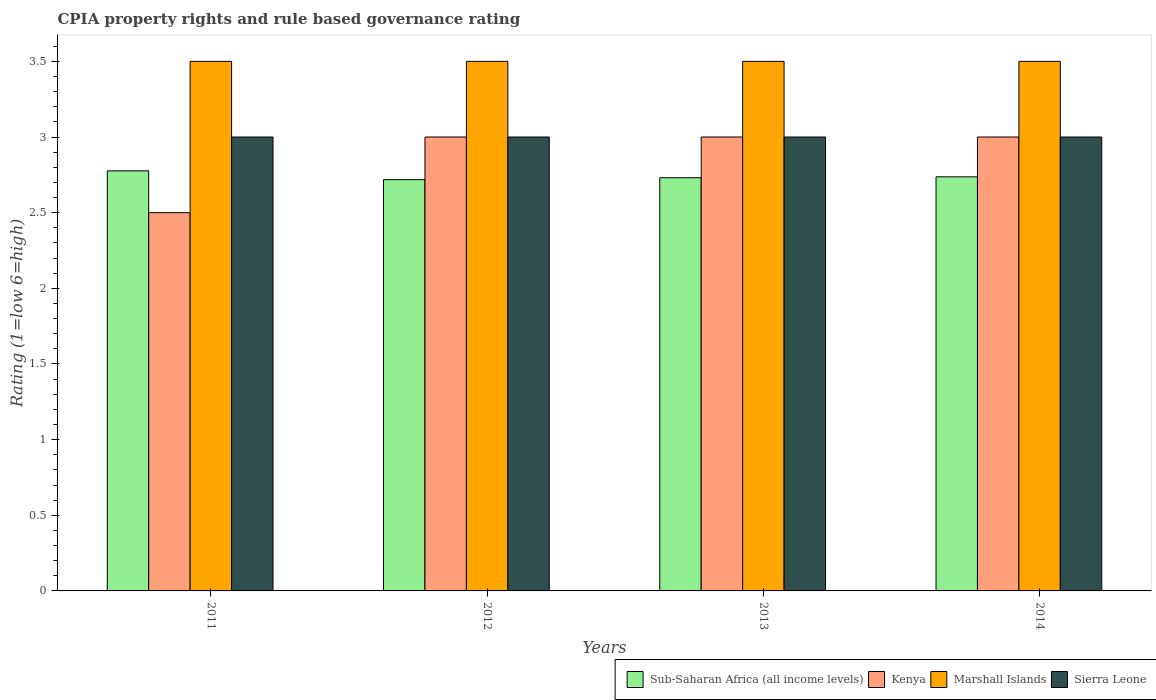How many different coloured bars are there?
Keep it short and to the point. 4. Are the number of bars per tick equal to the number of legend labels?
Make the answer very short. Yes. How many bars are there on the 1st tick from the left?
Provide a short and direct response. 4. How many bars are there on the 3rd tick from the right?
Offer a very short reply. 4. What is the label of the 2nd group of bars from the left?
Keep it short and to the point. 2012. In how many cases, is the number of bars for a given year not equal to the number of legend labels?
Ensure brevity in your answer.  0. What is the CPIA rating in Kenya in 2013?
Provide a short and direct response. 3. Across all years, what is the maximum CPIA rating in Sub-Saharan Africa (all income levels)?
Your answer should be compact. 2.78. In which year was the CPIA rating in Kenya minimum?
Provide a short and direct response. 2011. What is the total CPIA rating in Sub-Saharan Africa (all income levels) in the graph?
Your answer should be compact. 10.96. What is the difference between the CPIA rating in Sub-Saharan Africa (all income levels) in 2011 and the CPIA rating in Kenya in 2012?
Your answer should be compact. -0.22. What is the average CPIA rating in Marshall Islands per year?
Provide a short and direct response. 3.5. In the year 2011, what is the difference between the CPIA rating in Marshall Islands and CPIA rating in Sub-Saharan Africa (all income levels)?
Offer a very short reply. 0.72. What is the ratio of the CPIA rating in Sub-Saharan Africa (all income levels) in 2011 to that in 2014?
Your response must be concise. 1.01. Is the difference between the CPIA rating in Marshall Islands in 2012 and 2013 greater than the difference between the CPIA rating in Sub-Saharan Africa (all income levels) in 2012 and 2013?
Provide a succinct answer. Yes. What is the difference between the highest and the second highest CPIA rating in Sub-Saharan Africa (all income levels)?
Give a very brief answer. 0.04. In how many years, is the CPIA rating in Marshall Islands greater than the average CPIA rating in Marshall Islands taken over all years?
Offer a terse response. 0. Is the sum of the CPIA rating in Kenya in 2011 and 2014 greater than the maximum CPIA rating in Marshall Islands across all years?
Make the answer very short. Yes. What does the 4th bar from the left in 2014 represents?
Provide a succinct answer. Sierra Leone. What does the 2nd bar from the right in 2011 represents?
Give a very brief answer. Marshall Islands. Is it the case that in every year, the sum of the CPIA rating in Marshall Islands and CPIA rating in Kenya is greater than the CPIA rating in Sub-Saharan Africa (all income levels)?
Make the answer very short. Yes. How many years are there in the graph?
Keep it short and to the point. 4. What is the difference between two consecutive major ticks on the Y-axis?
Give a very brief answer. 0.5. What is the title of the graph?
Your answer should be compact. CPIA property rights and rule based governance rating. What is the label or title of the Y-axis?
Your answer should be very brief. Rating (1=low 6=high). What is the Rating (1=low 6=high) in Sub-Saharan Africa (all income levels) in 2011?
Offer a very short reply. 2.78. What is the Rating (1=low 6=high) in Sub-Saharan Africa (all income levels) in 2012?
Provide a short and direct response. 2.72. What is the Rating (1=low 6=high) of Marshall Islands in 2012?
Your answer should be very brief. 3.5. What is the Rating (1=low 6=high) in Sub-Saharan Africa (all income levels) in 2013?
Make the answer very short. 2.73. What is the Rating (1=low 6=high) in Sierra Leone in 2013?
Your answer should be compact. 3. What is the Rating (1=low 6=high) in Sub-Saharan Africa (all income levels) in 2014?
Make the answer very short. 2.74. What is the Rating (1=low 6=high) in Marshall Islands in 2014?
Your answer should be compact. 3.5. What is the Rating (1=low 6=high) in Sierra Leone in 2014?
Ensure brevity in your answer.  3. Across all years, what is the maximum Rating (1=low 6=high) of Sub-Saharan Africa (all income levels)?
Your answer should be very brief. 2.78. Across all years, what is the maximum Rating (1=low 6=high) of Marshall Islands?
Offer a very short reply. 3.5. Across all years, what is the maximum Rating (1=low 6=high) of Sierra Leone?
Provide a succinct answer. 3. Across all years, what is the minimum Rating (1=low 6=high) in Sub-Saharan Africa (all income levels)?
Offer a very short reply. 2.72. What is the total Rating (1=low 6=high) in Sub-Saharan Africa (all income levels) in the graph?
Provide a succinct answer. 10.96. What is the difference between the Rating (1=low 6=high) of Sub-Saharan Africa (all income levels) in 2011 and that in 2012?
Give a very brief answer. 0.06. What is the difference between the Rating (1=low 6=high) of Sub-Saharan Africa (all income levels) in 2011 and that in 2013?
Provide a succinct answer. 0.05. What is the difference between the Rating (1=low 6=high) of Marshall Islands in 2011 and that in 2013?
Offer a terse response. 0. What is the difference between the Rating (1=low 6=high) in Sub-Saharan Africa (all income levels) in 2011 and that in 2014?
Give a very brief answer. 0.04. What is the difference between the Rating (1=low 6=high) in Kenya in 2011 and that in 2014?
Make the answer very short. -0.5. What is the difference between the Rating (1=low 6=high) in Sub-Saharan Africa (all income levels) in 2012 and that in 2013?
Your answer should be very brief. -0.01. What is the difference between the Rating (1=low 6=high) in Sierra Leone in 2012 and that in 2013?
Make the answer very short. 0. What is the difference between the Rating (1=low 6=high) of Sub-Saharan Africa (all income levels) in 2012 and that in 2014?
Ensure brevity in your answer.  -0.02. What is the difference between the Rating (1=low 6=high) in Kenya in 2012 and that in 2014?
Make the answer very short. 0. What is the difference between the Rating (1=low 6=high) of Marshall Islands in 2012 and that in 2014?
Ensure brevity in your answer.  0. What is the difference between the Rating (1=low 6=high) in Sub-Saharan Africa (all income levels) in 2013 and that in 2014?
Give a very brief answer. -0.01. What is the difference between the Rating (1=low 6=high) in Kenya in 2013 and that in 2014?
Offer a very short reply. 0. What is the difference between the Rating (1=low 6=high) of Sub-Saharan Africa (all income levels) in 2011 and the Rating (1=low 6=high) of Kenya in 2012?
Provide a short and direct response. -0.22. What is the difference between the Rating (1=low 6=high) of Sub-Saharan Africa (all income levels) in 2011 and the Rating (1=low 6=high) of Marshall Islands in 2012?
Ensure brevity in your answer.  -0.72. What is the difference between the Rating (1=low 6=high) in Sub-Saharan Africa (all income levels) in 2011 and the Rating (1=low 6=high) in Sierra Leone in 2012?
Your answer should be very brief. -0.22. What is the difference between the Rating (1=low 6=high) of Marshall Islands in 2011 and the Rating (1=low 6=high) of Sierra Leone in 2012?
Your answer should be very brief. 0.5. What is the difference between the Rating (1=low 6=high) in Sub-Saharan Africa (all income levels) in 2011 and the Rating (1=low 6=high) in Kenya in 2013?
Make the answer very short. -0.22. What is the difference between the Rating (1=low 6=high) in Sub-Saharan Africa (all income levels) in 2011 and the Rating (1=low 6=high) in Marshall Islands in 2013?
Your answer should be compact. -0.72. What is the difference between the Rating (1=low 6=high) in Sub-Saharan Africa (all income levels) in 2011 and the Rating (1=low 6=high) in Sierra Leone in 2013?
Offer a very short reply. -0.22. What is the difference between the Rating (1=low 6=high) in Kenya in 2011 and the Rating (1=low 6=high) in Marshall Islands in 2013?
Your answer should be very brief. -1. What is the difference between the Rating (1=low 6=high) of Kenya in 2011 and the Rating (1=low 6=high) of Sierra Leone in 2013?
Your response must be concise. -0.5. What is the difference between the Rating (1=low 6=high) of Marshall Islands in 2011 and the Rating (1=low 6=high) of Sierra Leone in 2013?
Your answer should be compact. 0.5. What is the difference between the Rating (1=low 6=high) of Sub-Saharan Africa (all income levels) in 2011 and the Rating (1=low 6=high) of Kenya in 2014?
Offer a very short reply. -0.22. What is the difference between the Rating (1=low 6=high) of Sub-Saharan Africa (all income levels) in 2011 and the Rating (1=low 6=high) of Marshall Islands in 2014?
Make the answer very short. -0.72. What is the difference between the Rating (1=low 6=high) of Sub-Saharan Africa (all income levels) in 2011 and the Rating (1=low 6=high) of Sierra Leone in 2014?
Make the answer very short. -0.22. What is the difference between the Rating (1=low 6=high) in Kenya in 2011 and the Rating (1=low 6=high) in Marshall Islands in 2014?
Offer a very short reply. -1. What is the difference between the Rating (1=low 6=high) of Marshall Islands in 2011 and the Rating (1=low 6=high) of Sierra Leone in 2014?
Your answer should be very brief. 0.5. What is the difference between the Rating (1=low 6=high) in Sub-Saharan Africa (all income levels) in 2012 and the Rating (1=low 6=high) in Kenya in 2013?
Your response must be concise. -0.28. What is the difference between the Rating (1=low 6=high) of Sub-Saharan Africa (all income levels) in 2012 and the Rating (1=low 6=high) of Marshall Islands in 2013?
Offer a terse response. -0.78. What is the difference between the Rating (1=low 6=high) of Sub-Saharan Africa (all income levels) in 2012 and the Rating (1=low 6=high) of Sierra Leone in 2013?
Offer a very short reply. -0.28. What is the difference between the Rating (1=low 6=high) of Kenya in 2012 and the Rating (1=low 6=high) of Marshall Islands in 2013?
Offer a terse response. -0.5. What is the difference between the Rating (1=low 6=high) of Sub-Saharan Africa (all income levels) in 2012 and the Rating (1=low 6=high) of Kenya in 2014?
Provide a succinct answer. -0.28. What is the difference between the Rating (1=low 6=high) of Sub-Saharan Africa (all income levels) in 2012 and the Rating (1=low 6=high) of Marshall Islands in 2014?
Your answer should be compact. -0.78. What is the difference between the Rating (1=low 6=high) of Sub-Saharan Africa (all income levels) in 2012 and the Rating (1=low 6=high) of Sierra Leone in 2014?
Your answer should be very brief. -0.28. What is the difference between the Rating (1=low 6=high) of Kenya in 2012 and the Rating (1=low 6=high) of Marshall Islands in 2014?
Provide a succinct answer. -0.5. What is the difference between the Rating (1=low 6=high) in Kenya in 2012 and the Rating (1=low 6=high) in Sierra Leone in 2014?
Ensure brevity in your answer.  0. What is the difference between the Rating (1=low 6=high) of Marshall Islands in 2012 and the Rating (1=low 6=high) of Sierra Leone in 2014?
Your response must be concise. 0.5. What is the difference between the Rating (1=low 6=high) in Sub-Saharan Africa (all income levels) in 2013 and the Rating (1=low 6=high) in Kenya in 2014?
Your answer should be very brief. -0.27. What is the difference between the Rating (1=low 6=high) in Sub-Saharan Africa (all income levels) in 2013 and the Rating (1=low 6=high) in Marshall Islands in 2014?
Your answer should be compact. -0.77. What is the difference between the Rating (1=low 6=high) of Sub-Saharan Africa (all income levels) in 2013 and the Rating (1=low 6=high) of Sierra Leone in 2014?
Your answer should be compact. -0.27. What is the difference between the Rating (1=low 6=high) in Kenya in 2013 and the Rating (1=low 6=high) in Marshall Islands in 2014?
Provide a short and direct response. -0.5. What is the difference between the Rating (1=low 6=high) in Marshall Islands in 2013 and the Rating (1=low 6=high) in Sierra Leone in 2014?
Your answer should be very brief. 0.5. What is the average Rating (1=low 6=high) in Sub-Saharan Africa (all income levels) per year?
Give a very brief answer. 2.74. What is the average Rating (1=low 6=high) of Kenya per year?
Your response must be concise. 2.88. What is the average Rating (1=low 6=high) of Marshall Islands per year?
Offer a terse response. 3.5. In the year 2011, what is the difference between the Rating (1=low 6=high) in Sub-Saharan Africa (all income levels) and Rating (1=low 6=high) in Kenya?
Provide a succinct answer. 0.28. In the year 2011, what is the difference between the Rating (1=low 6=high) in Sub-Saharan Africa (all income levels) and Rating (1=low 6=high) in Marshall Islands?
Your response must be concise. -0.72. In the year 2011, what is the difference between the Rating (1=low 6=high) in Sub-Saharan Africa (all income levels) and Rating (1=low 6=high) in Sierra Leone?
Provide a succinct answer. -0.22. In the year 2011, what is the difference between the Rating (1=low 6=high) of Kenya and Rating (1=low 6=high) of Marshall Islands?
Provide a short and direct response. -1. In the year 2011, what is the difference between the Rating (1=low 6=high) of Marshall Islands and Rating (1=low 6=high) of Sierra Leone?
Your answer should be compact. 0.5. In the year 2012, what is the difference between the Rating (1=low 6=high) of Sub-Saharan Africa (all income levels) and Rating (1=low 6=high) of Kenya?
Offer a terse response. -0.28. In the year 2012, what is the difference between the Rating (1=low 6=high) in Sub-Saharan Africa (all income levels) and Rating (1=low 6=high) in Marshall Islands?
Offer a terse response. -0.78. In the year 2012, what is the difference between the Rating (1=low 6=high) in Sub-Saharan Africa (all income levels) and Rating (1=low 6=high) in Sierra Leone?
Your answer should be compact. -0.28. In the year 2012, what is the difference between the Rating (1=low 6=high) of Kenya and Rating (1=low 6=high) of Marshall Islands?
Give a very brief answer. -0.5. In the year 2012, what is the difference between the Rating (1=low 6=high) in Kenya and Rating (1=low 6=high) in Sierra Leone?
Give a very brief answer. 0. In the year 2013, what is the difference between the Rating (1=low 6=high) in Sub-Saharan Africa (all income levels) and Rating (1=low 6=high) in Kenya?
Your answer should be very brief. -0.27. In the year 2013, what is the difference between the Rating (1=low 6=high) of Sub-Saharan Africa (all income levels) and Rating (1=low 6=high) of Marshall Islands?
Make the answer very short. -0.77. In the year 2013, what is the difference between the Rating (1=low 6=high) in Sub-Saharan Africa (all income levels) and Rating (1=low 6=high) in Sierra Leone?
Make the answer very short. -0.27. In the year 2013, what is the difference between the Rating (1=low 6=high) of Marshall Islands and Rating (1=low 6=high) of Sierra Leone?
Your answer should be compact. 0.5. In the year 2014, what is the difference between the Rating (1=low 6=high) of Sub-Saharan Africa (all income levels) and Rating (1=low 6=high) of Kenya?
Offer a very short reply. -0.26. In the year 2014, what is the difference between the Rating (1=low 6=high) of Sub-Saharan Africa (all income levels) and Rating (1=low 6=high) of Marshall Islands?
Make the answer very short. -0.76. In the year 2014, what is the difference between the Rating (1=low 6=high) in Sub-Saharan Africa (all income levels) and Rating (1=low 6=high) in Sierra Leone?
Provide a succinct answer. -0.26. What is the ratio of the Rating (1=low 6=high) of Sub-Saharan Africa (all income levels) in 2011 to that in 2012?
Keep it short and to the point. 1.02. What is the ratio of the Rating (1=low 6=high) of Kenya in 2011 to that in 2012?
Provide a succinct answer. 0.83. What is the ratio of the Rating (1=low 6=high) of Sub-Saharan Africa (all income levels) in 2011 to that in 2013?
Make the answer very short. 1.02. What is the ratio of the Rating (1=low 6=high) in Kenya in 2011 to that in 2013?
Keep it short and to the point. 0.83. What is the ratio of the Rating (1=low 6=high) of Marshall Islands in 2011 to that in 2013?
Offer a very short reply. 1. What is the ratio of the Rating (1=low 6=high) in Sierra Leone in 2011 to that in 2013?
Offer a very short reply. 1. What is the ratio of the Rating (1=low 6=high) of Sub-Saharan Africa (all income levels) in 2011 to that in 2014?
Ensure brevity in your answer.  1.01. What is the ratio of the Rating (1=low 6=high) in Kenya in 2011 to that in 2014?
Provide a succinct answer. 0.83. What is the ratio of the Rating (1=low 6=high) in Sierra Leone in 2011 to that in 2014?
Provide a short and direct response. 1. What is the ratio of the Rating (1=low 6=high) in Kenya in 2012 to that in 2014?
Give a very brief answer. 1. What is the ratio of the Rating (1=low 6=high) of Marshall Islands in 2012 to that in 2014?
Make the answer very short. 1. What is the ratio of the Rating (1=low 6=high) of Sierra Leone in 2012 to that in 2014?
Provide a succinct answer. 1. What is the ratio of the Rating (1=low 6=high) of Sierra Leone in 2013 to that in 2014?
Ensure brevity in your answer.  1. What is the difference between the highest and the second highest Rating (1=low 6=high) in Sub-Saharan Africa (all income levels)?
Offer a terse response. 0.04. What is the difference between the highest and the second highest Rating (1=low 6=high) of Kenya?
Your response must be concise. 0. What is the difference between the highest and the second highest Rating (1=low 6=high) of Sierra Leone?
Your answer should be very brief. 0. What is the difference between the highest and the lowest Rating (1=low 6=high) in Sub-Saharan Africa (all income levels)?
Keep it short and to the point. 0.06. What is the difference between the highest and the lowest Rating (1=low 6=high) in Kenya?
Ensure brevity in your answer.  0.5. What is the difference between the highest and the lowest Rating (1=low 6=high) in Marshall Islands?
Your answer should be very brief. 0. 